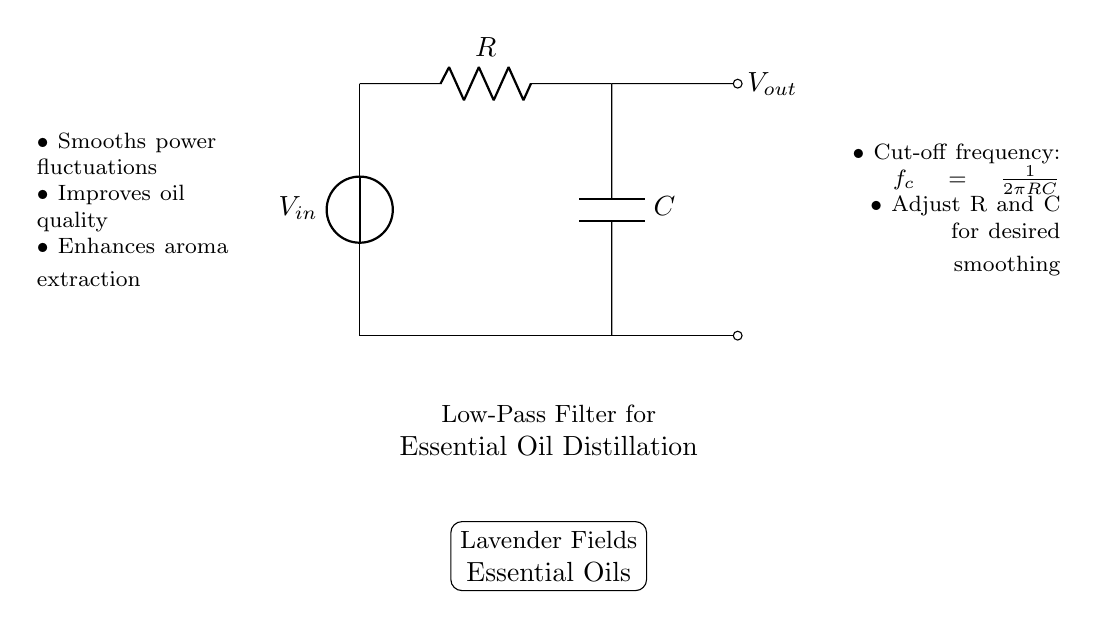What type of filter is represented in this circuit? The circuit is a low-pass filter, which is indicated by the label and the arrangement of the resistor and capacitor. Low-pass filters allow low-frequency signals to pass while attenuating high-frequency signals.
Answer: low-pass filter What are the two main components in this circuit? The main components shown are a resistor and a capacitor, which work together in the filtering process. The resistor is connected in series and the capacitor in parallel with the output.
Answer: resistor and capacitor What is the function of this low-pass filter? The function of the filter is to smooth out power fluctuations, as indicated in the circuit description. This is crucial in maintaining consistent performance in essential oil distillation processes.
Answer: smooth power fluctuations What does the cutoff frequency depend on in this circuit? The cutoff frequency depends on the values of resistance and capacitance, as stated in the formula provided ($f_c = \frac{1}{2\pi RC}$). Adjusting R and C will change the frequency at which the filter begins to attenuate the input signal.
Answer: resistance and capacitance What is the cutoff frequency formula for this filter? The cutoff frequency formula is given as $f_c = \frac{1}{2\pi RC}$. This relationship shows how the cutoff frequency is inversely proportional to the product of resistance and capacitance.
Answer: f_c = 1/(2πRC) How does this filter enhance aroma extraction in essential oils? By smoothing out power fluctuations, the low-pass filter improves the consistency of the distillation process, thereby enhancing the quality of aroma extraction from the oils. Consistent power supply helps maintain optimal operating conditions.
Answer: improves aroma extraction What is the output voltage label in the circuit? The output voltage is labeled as V_out in the diagram, which represents the voltage across the capacitor in a low-pass filter circuit. This voltage reflects the smoothed result after passing through the filter.
Answer: V_out 